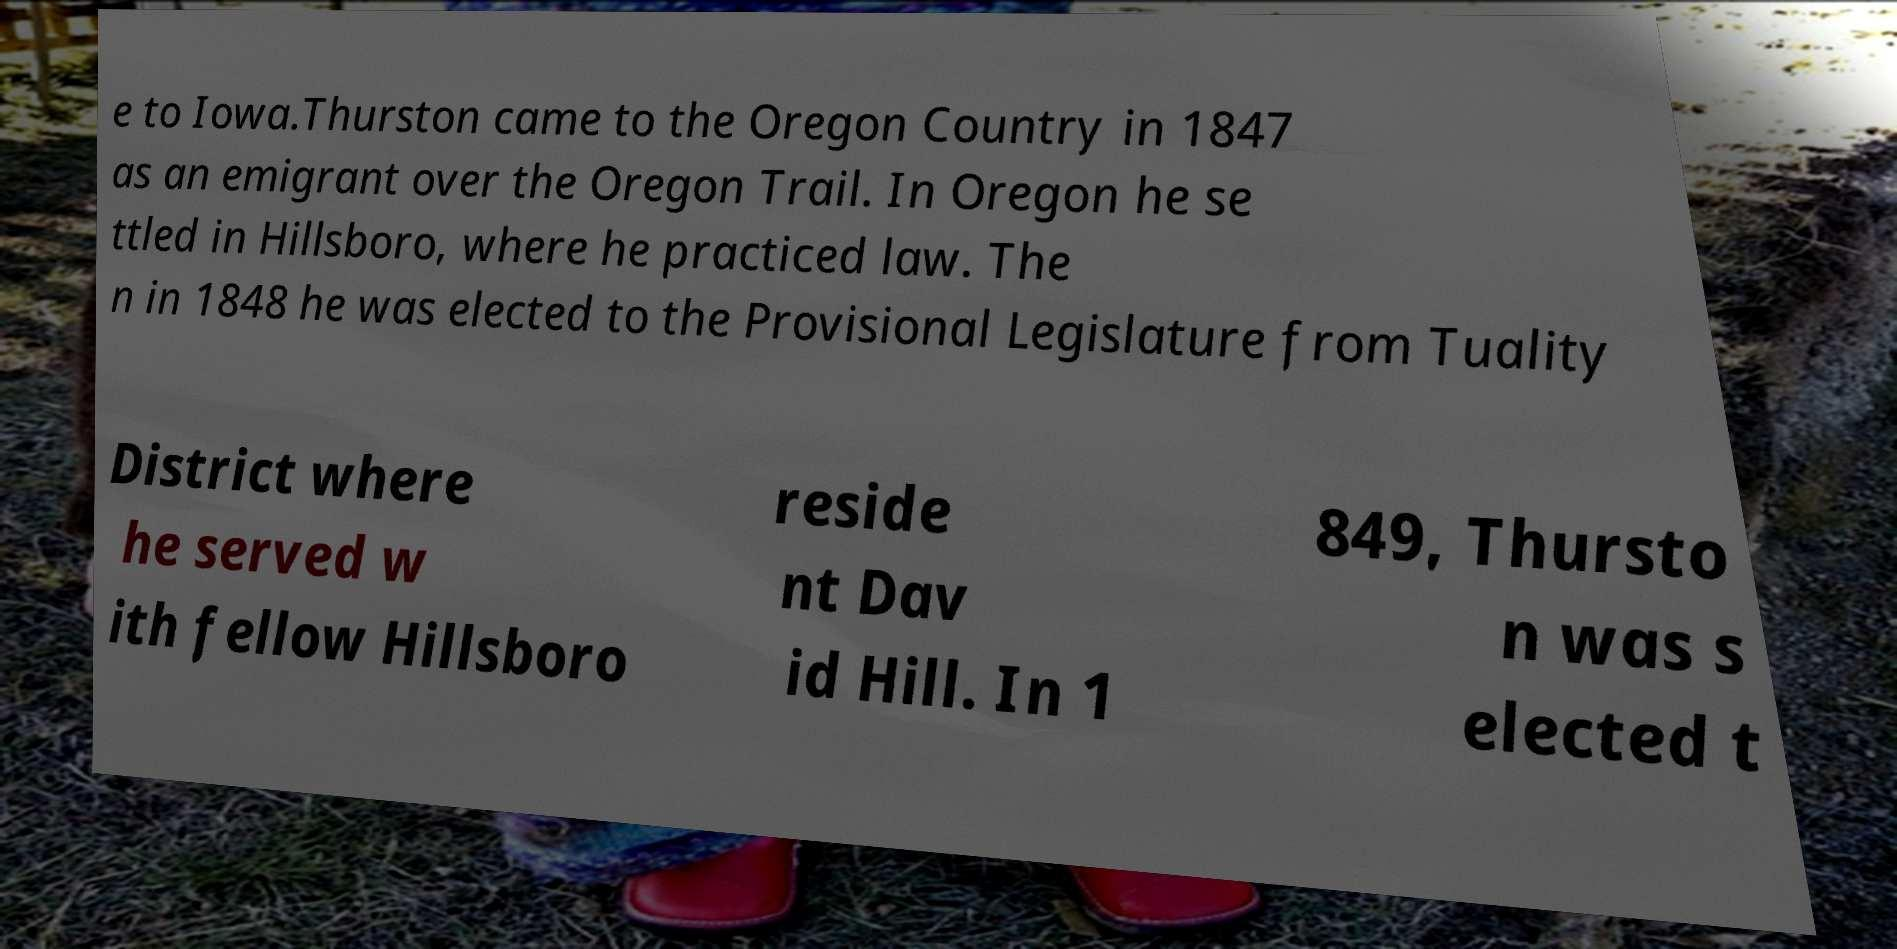Could you extract and type out the text from this image? e to Iowa.Thurston came to the Oregon Country in 1847 as an emigrant over the Oregon Trail. In Oregon he se ttled in Hillsboro, where he practiced law. The n in 1848 he was elected to the Provisional Legislature from Tuality District where he served w ith fellow Hillsboro reside nt Dav id Hill. In 1 849, Thursto n was s elected t 